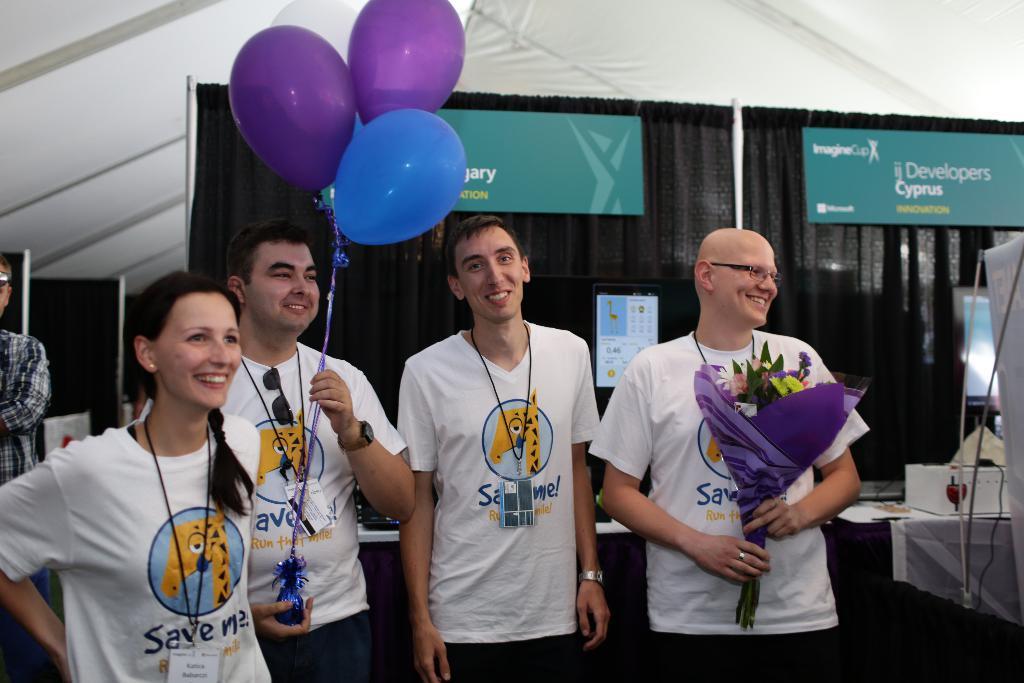Could you give a brief overview of what you see in this image? In this image we can see a few people standing, among them two are holding the objects, behind them, we can see the curtains, calendar and boards with some text, also we can see some objects on the table. 